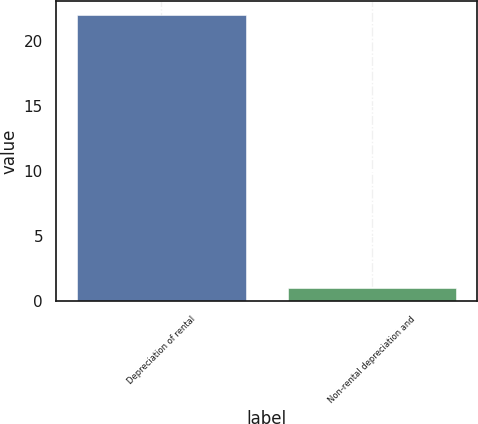<chart> <loc_0><loc_0><loc_500><loc_500><bar_chart><fcel>Depreciation of rental<fcel>Non-rental depreciation and<nl><fcel>22<fcel>1<nl></chart> 